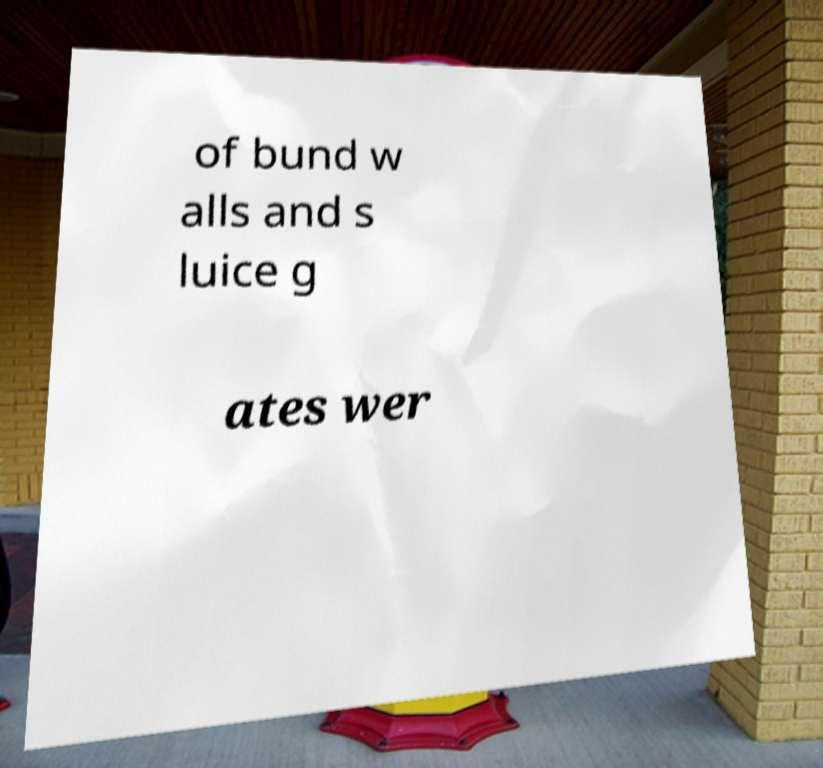Could you assist in decoding the text presented in this image and type it out clearly? of bund w alls and s luice g ates wer 